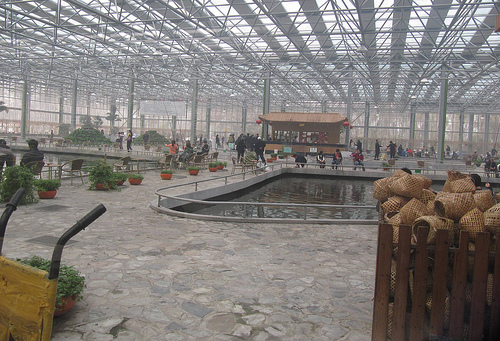<image>
Is the water to the right of the tree pot? Yes. From this viewpoint, the water is positioned to the right side relative to the tree pot. Is the plant in the pond? No. The plant is not contained within the pond. These objects have a different spatial relationship. 